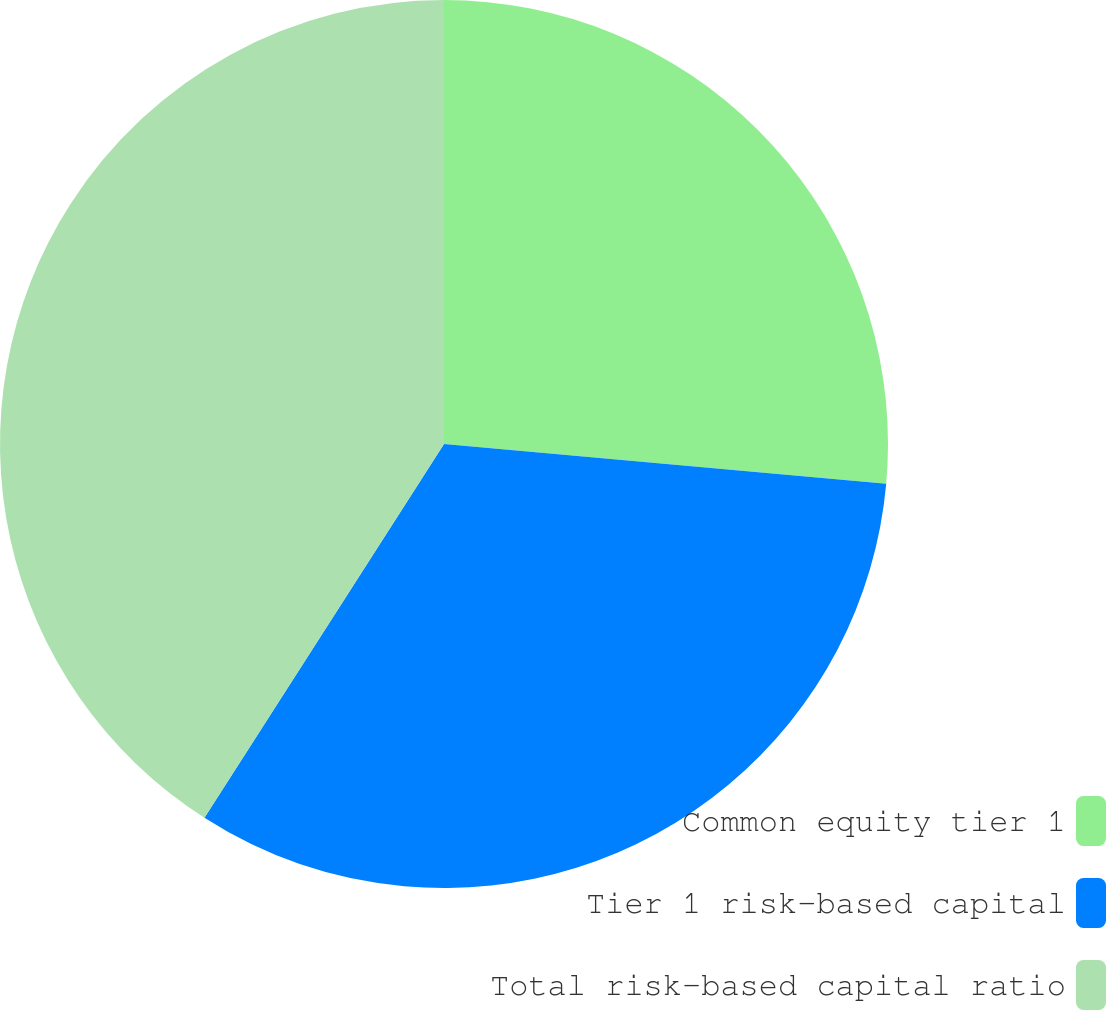Convert chart. <chart><loc_0><loc_0><loc_500><loc_500><pie_chart><fcel>Common equity tier 1<fcel>Tier 1 risk-based capital<fcel>Total risk-based capital ratio<nl><fcel>26.43%<fcel>32.64%<fcel>40.93%<nl></chart> 